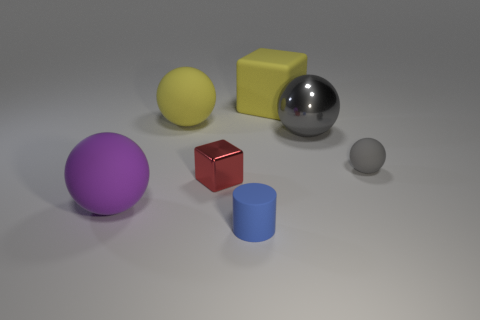The big metal sphere is what color?
Your response must be concise. Gray. Is the shape of the small matte object that is to the left of the rubber cube the same as  the small metallic thing?
Your response must be concise. No. How many objects are either gray metallic objects or objects that are right of the purple thing?
Provide a succinct answer. 6. Are the block to the right of the small cylinder and the tiny cylinder made of the same material?
Offer a terse response. Yes. Are there any other things that have the same size as the metallic sphere?
Provide a succinct answer. Yes. What material is the large ball on the left side of the big yellow matte thing that is to the left of the tiny blue rubber cylinder?
Give a very brief answer. Rubber. Are there more small rubber things behind the purple rubber ball than blue cylinders that are behind the big gray metal thing?
Make the answer very short. Yes. What size is the purple object?
Your answer should be compact. Large. Do the large thing that is behind the large yellow rubber ball and the metallic sphere have the same color?
Ensure brevity in your answer.  No. Is there anything else that has the same shape as the gray rubber thing?
Give a very brief answer. Yes. 